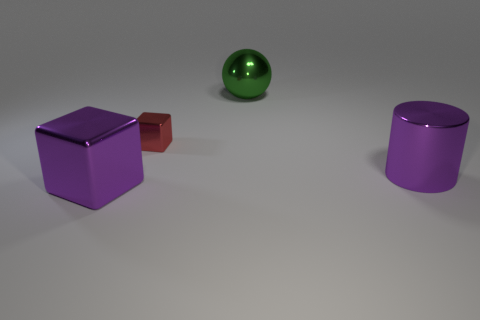Is there anything else that is the same size as the red metal thing?
Offer a terse response. No. Do the tiny red block and the purple object on the left side of the large sphere have the same material?
Provide a succinct answer. Yes. There is a purple object that is the same size as the purple shiny cube; what is it made of?
Offer a very short reply. Metal. Is there a gray matte cylinder of the same size as the metallic cylinder?
Give a very brief answer. No. What is the shape of the purple object that is the same size as the purple shiny cylinder?
Your answer should be compact. Cube. How many other things are the same color as the metal sphere?
Make the answer very short. 0. There is a large shiny thing that is both in front of the big shiny ball and behind the large block; what shape is it?
Your answer should be very brief. Cylinder. There is a big metallic thing behind the big purple object that is on the right side of the metallic sphere; is there a green thing in front of it?
Provide a succinct answer. No. What number of other objects are there of the same material as the purple cube?
Give a very brief answer. 3. How many blue cubes are there?
Your answer should be compact. 0. 